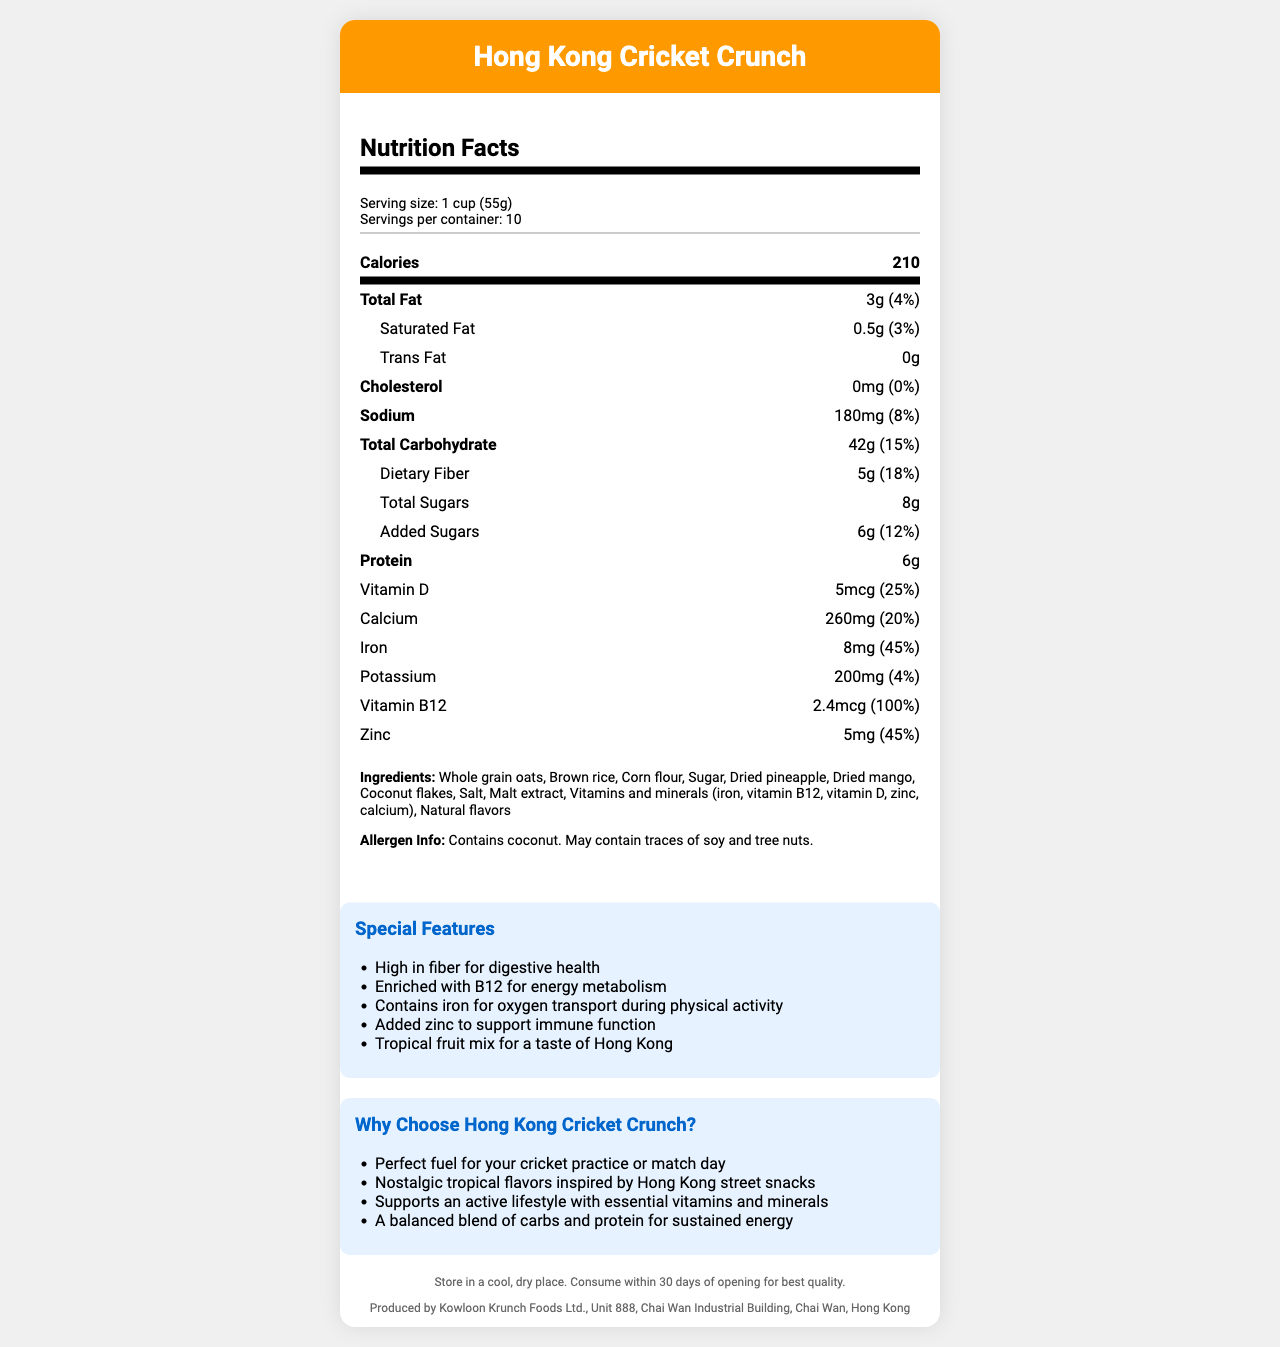what is the serving size for Hong Kong Cricket Crunch? The serving size is mentioned in the serving info section as "1 cup (55g)".
Answer: 1 cup (55g) how many calories are in one serving? The number of calories per serving is listed under the main nutrients section as "Calories: 210".
Answer: 210 what is the percent daily value of dietary fiber per serving? The percent daily value of dietary fiber is shown in the nutrient row for dietary fiber as "18%".
Answer: 18% what are the special features of Hong Kong Cricket Crunch? The special features are listed under the "Special Features" section.
Answer: High in fiber for digestive health, Enriched with B12 for energy metabolism, Contains iron for oxygen transport during physical activity, Added zinc to support immune function, Tropical fruit mix for a taste of Hong Kong how much added sugar is in each serving? The amount of added sugars is mentioned in the sub-nutrient row for total sugars as "Added Sugars: 6g".
Answer: 6g The product contains which type of allergens? A. Soy B. Milk C. Coconut D. Peanuts The allergen information states "Contains coconut. May contain traces of soy and tree nuts."
Answer: C. Coconut Which vitamin has 100% of the daily value per serving? A. Vitamin D B. Calcium C. Iron D. Vitamin B12 The nutrients list shows that Vitamin B12 has 100% of the daily value.
Answer: D. Vitamin B12 Does the product contain trans fat? The nutrient row for trans fat shows the amount as "0g", indicating it does not contain trans fat.
Answer: No Is this cereal suitable for individuals with tree nut allergies? The allergen info states "May contain traces of soy and tree nuts," so it's unclear if it is completely safe for individuals with tree nut allergies.
Answer: I don't know Summarize the main idea of the document. The document includes comprehensive information about the product, emphasizing its nutritional benefits, flavors, and suitability for an active lifestyle.
Answer: Hong Kong Cricket Crunch is a vitamin-enriched breakfast cereal designed for active lifestyles, with nostalgic tropical flavors inspired by Hong Kong. The document provides detailed nutrition facts, ingredients, allergen information, special features, marketing claims, storage instructions, and manufacturer details. How many servings are there in a container? The serving info section lists "Servings per container: 10".
Answer: 10 Which ingredient gives the cereal a tropical flavor? The ingredients list includes "Dried pineapple, Dried mango, Coconut flakes" which contribute to the tropical flavor.
Answer: Dried pineapple, Dried mango, Coconut flakes Which company manufactures Hong Kong Cricket Crunch? The manufacturer's information at the bottom of the document states the product is produced by "Kowloon Krunch Foods Ltd."
Answer: Kowloon Krunch Foods Ltd. what is the storage instruction for Hong Kong Cricket Crunch? The storage instruction is listed in the footer section as "Store in a cool, dry place. Consume within 30 days of opening for best quality."
Answer: Store in a cool, dry place. Consume within 30 days of opening for best quality. how much sodium is in each serving? The amount of sodium per serving is listed in the nutrient row as "Sodium: 180mg".
Answer: 180mg 